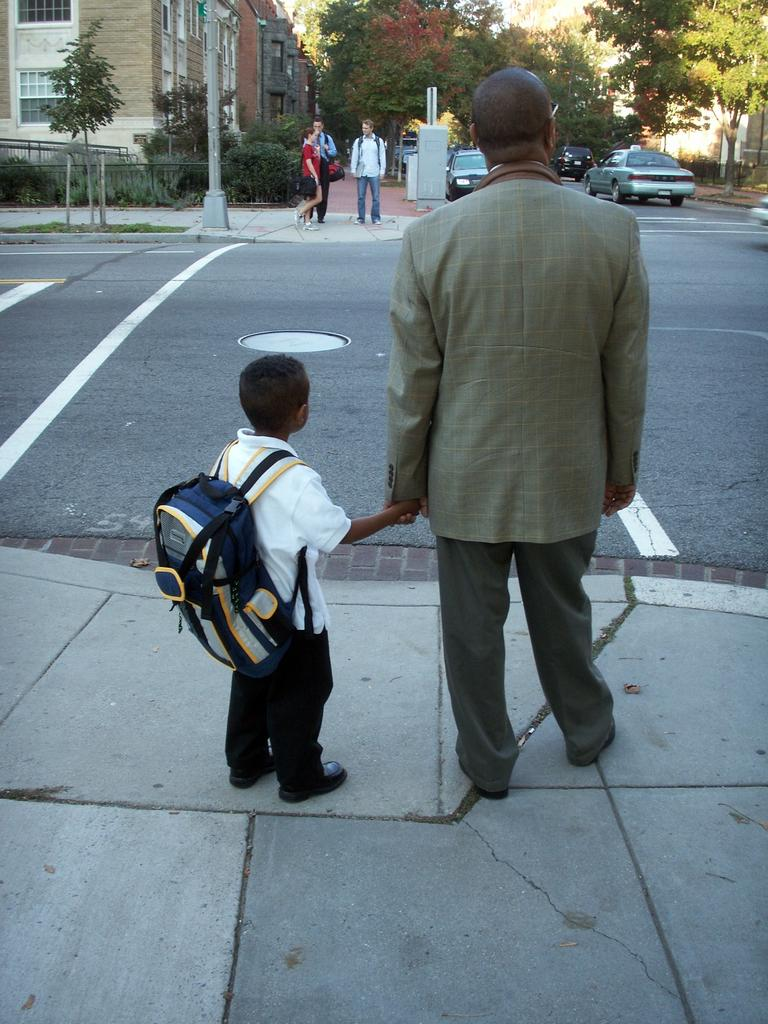How many people are in the image? There are people in the image, but the exact number is not specified. What are some people wearing in the image? Some people are wearing bags in the image. What can be seen in the background of the image? In the background of the image, there are vehicles, poles, buildings, and trees. What type of barrier is present in the image? There is a fence in the image. How many brothers are visible in the image? There is no mention of brothers in the image, so we cannot determine their presence or number. What are the people in the image looking at? The facts provided do not specify what the people in the image are looking at, so we cannot answer this question. 